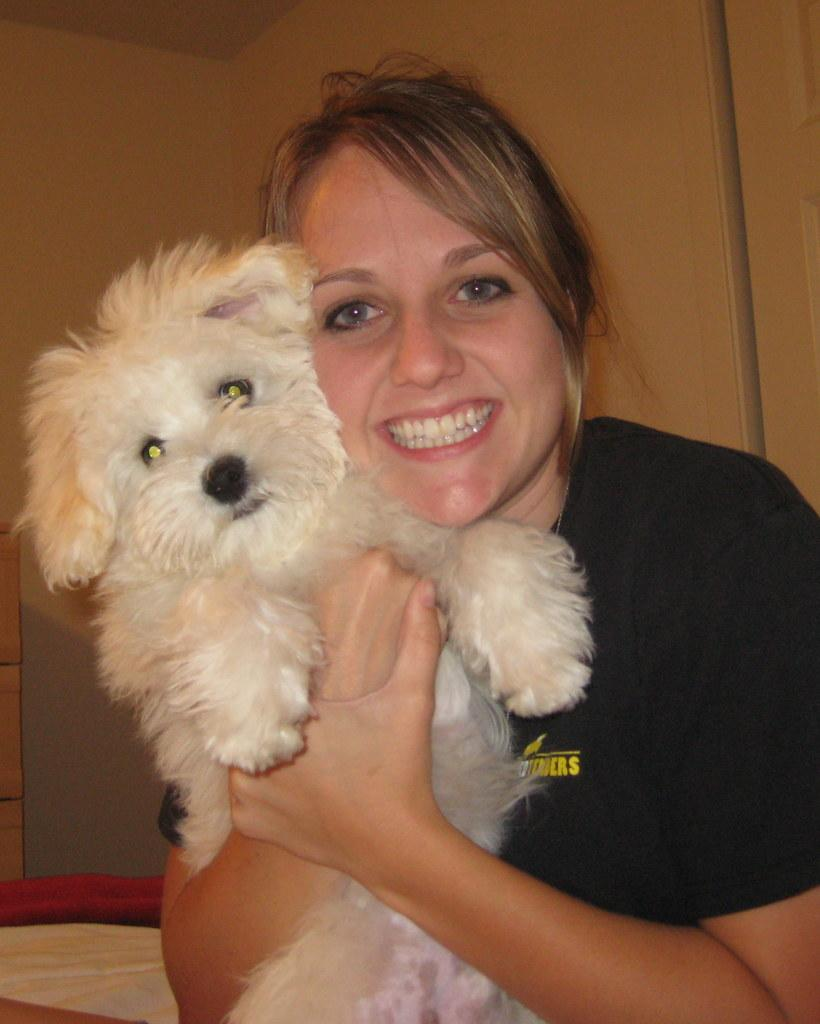Who is present in the image? There is a woman in the image. What is the woman doing in the image? The woman is smiling in the image. What is the woman holding in the image? The woman is holding a dog in the image. What is visible behind the woman in the image? There is a wall behind the woman in the image. What grade is the woman teaching in the image? There is no indication in the image that the woman is teaching, nor is there any reference to a grade. 